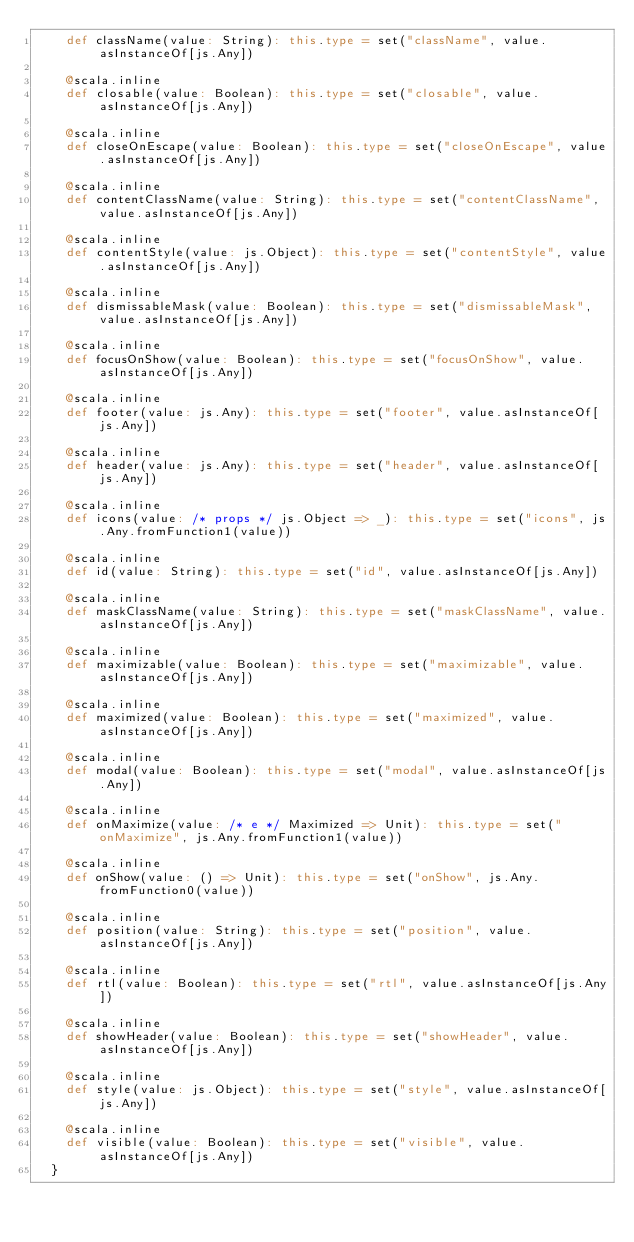Convert code to text. <code><loc_0><loc_0><loc_500><loc_500><_Scala_>    def className(value: String): this.type = set("className", value.asInstanceOf[js.Any])
    
    @scala.inline
    def closable(value: Boolean): this.type = set("closable", value.asInstanceOf[js.Any])
    
    @scala.inline
    def closeOnEscape(value: Boolean): this.type = set("closeOnEscape", value.asInstanceOf[js.Any])
    
    @scala.inline
    def contentClassName(value: String): this.type = set("contentClassName", value.asInstanceOf[js.Any])
    
    @scala.inline
    def contentStyle(value: js.Object): this.type = set("contentStyle", value.asInstanceOf[js.Any])
    
    @scala.inline
    def dismissableMask(value: Boolean): this.type = set("dismissableMask", value.asInstanceOf[js.Any])
    
    @scala.inline
    def focusOnShow(value: Boolean): this.type = set("focusOnShow", value.asInstanceOf[js.Any])
    
    @scala.inline
    def footer(value: js.Any): this.type = set("footer", value.asInstanceOf[js.Any])
    
    @scala.inline
    def header(value: js.Any): this.type = set("header", value.asInstanceOf[js.Any])
    
    @scala.inline
    def icons(value: /* props */ js.Object => _): this.type = set("icons", js.Any.fromFunction1(value))
    
    @scala.inline
    def id(value: String): this.type = set("id", value.asInstanceOf[js.Any])
    
    @scala.inline
    def maskClassName(value: String): this.type = set("maskClassName", value.asInstanceOf[js.Any])
    
    @scala.inline
    def maximizable(value: Boolean): this.type = set("maximizable", value.asInstanceOf[js.Any])
    
    @scala.inline
    def maximized(value: Boolean): this.type = set("maximized", value.asInstanceOf[js.Any])
    
    @scala.inline
    def modal(value: Boolean): this.type = set("modal", value.asInstanceOf[js.Any])
    
    @scala.inline
    def onMaximize(value: /* e */ Maximized => Unit): this.type = set("onMaximize", js.Any.fromFunction1(value))
    
    @scala.inline
    def onShow(value: () => Unit): this.type = set("onShow", js.Any.fromFunction0(value))
    
    @scala.inline
    def position(value: String): this.type = set("position", value.asInstanceOf[js.Any])
    
    @scala.inline
    def rtl(value: Boolean): this.type = set("rtl", value.asInstanceOf[js.Any])
    
    @scala.inline
    def showHeader(value: Boolean): this.type = set("showHeader", value.asInstanceOf[js.Any])
    
    @scala.inline
    def style(value: js.Object): this.type = set("style", value.asInstanceOf[js.Any])
    
    @scala.inline
    def visible(value: Boolean): this.type = set("visible", value.asInstanceOf[js.Any])
  }
  </code> 